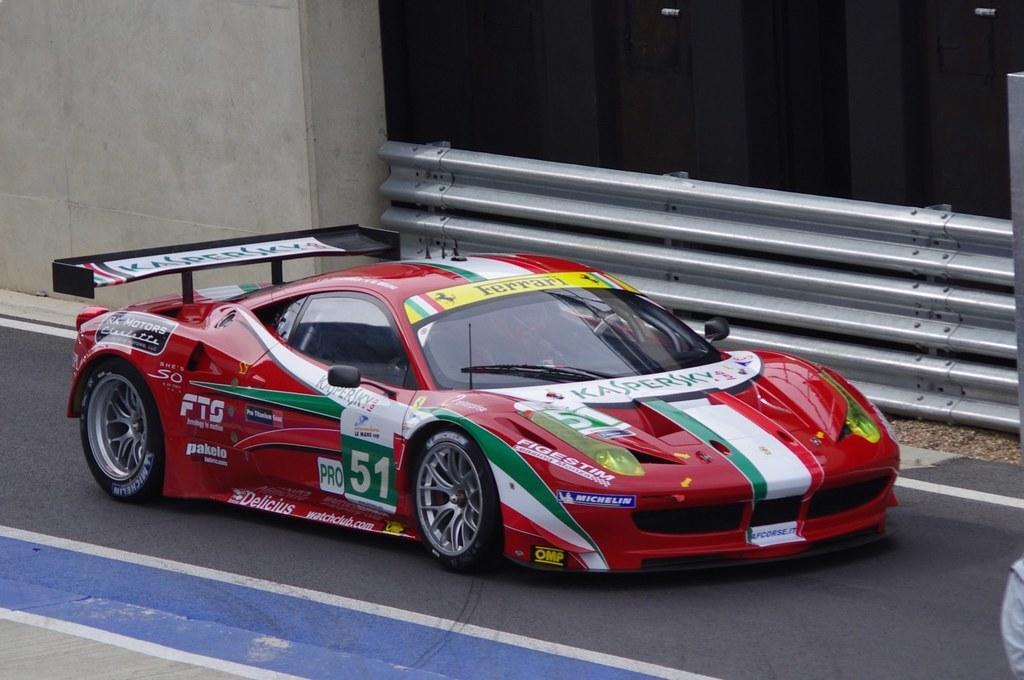Describe this image in one or two sentences. In the front of the image I can see car is on the road. In the background of the image there is a wall and railing. 